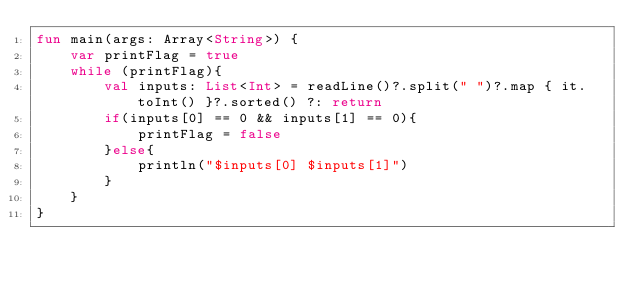Convert code to text. <code><loc_0><loc_0><loc_500><loc_500><_Kotlin_>fun main(args: Array<String>) {
    var printFlag = true
    while (printFlag){
        val inputs: List<Int> = readLine()?.split(" ")?.map { it.toInt() }?.sorted() ?: return
        if(inputs[0] == 0 && inputs[1] == 0){
            printFlag = false
        }else{
            println("$inputs[0] $inputs[1]")
        }
    }
}
</code> 